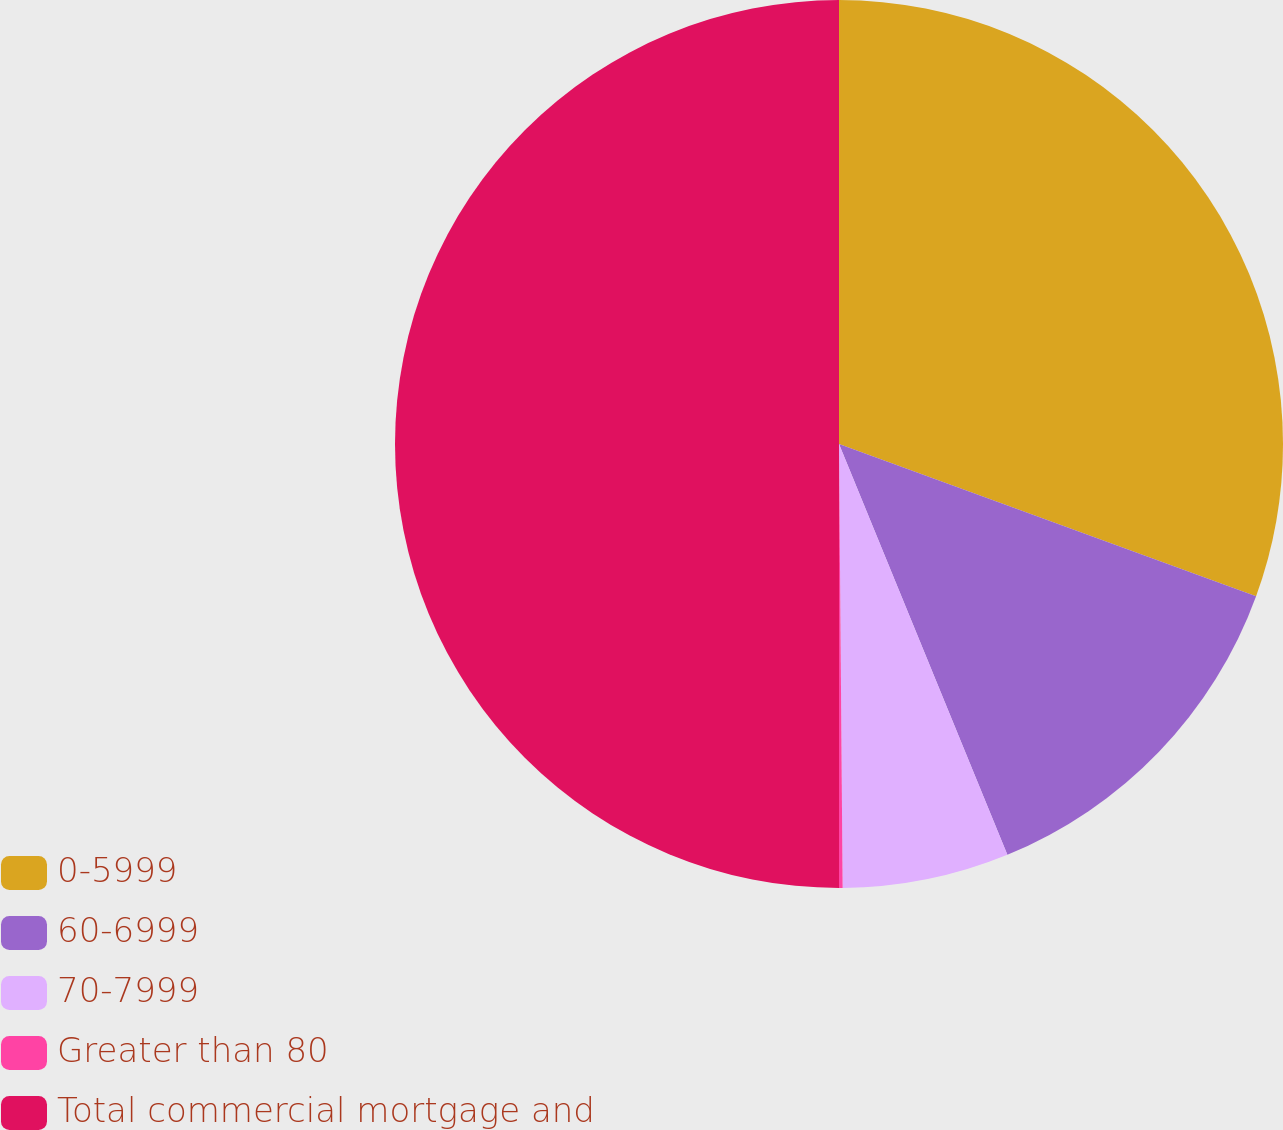Convert chart. <chart><loc_0><loc_0><loc_500><loc_500><pie_chart><fcel>0-5999<fcel>60-6999<fcel>70-7999<fcel>Greater than 80<fcel>Total commercial mortgage and<nl><fcel>30.57%<fcel>13.24%<fcel>6.06%<fcel>0.13%<fcel>50.0%<nl></chart> 